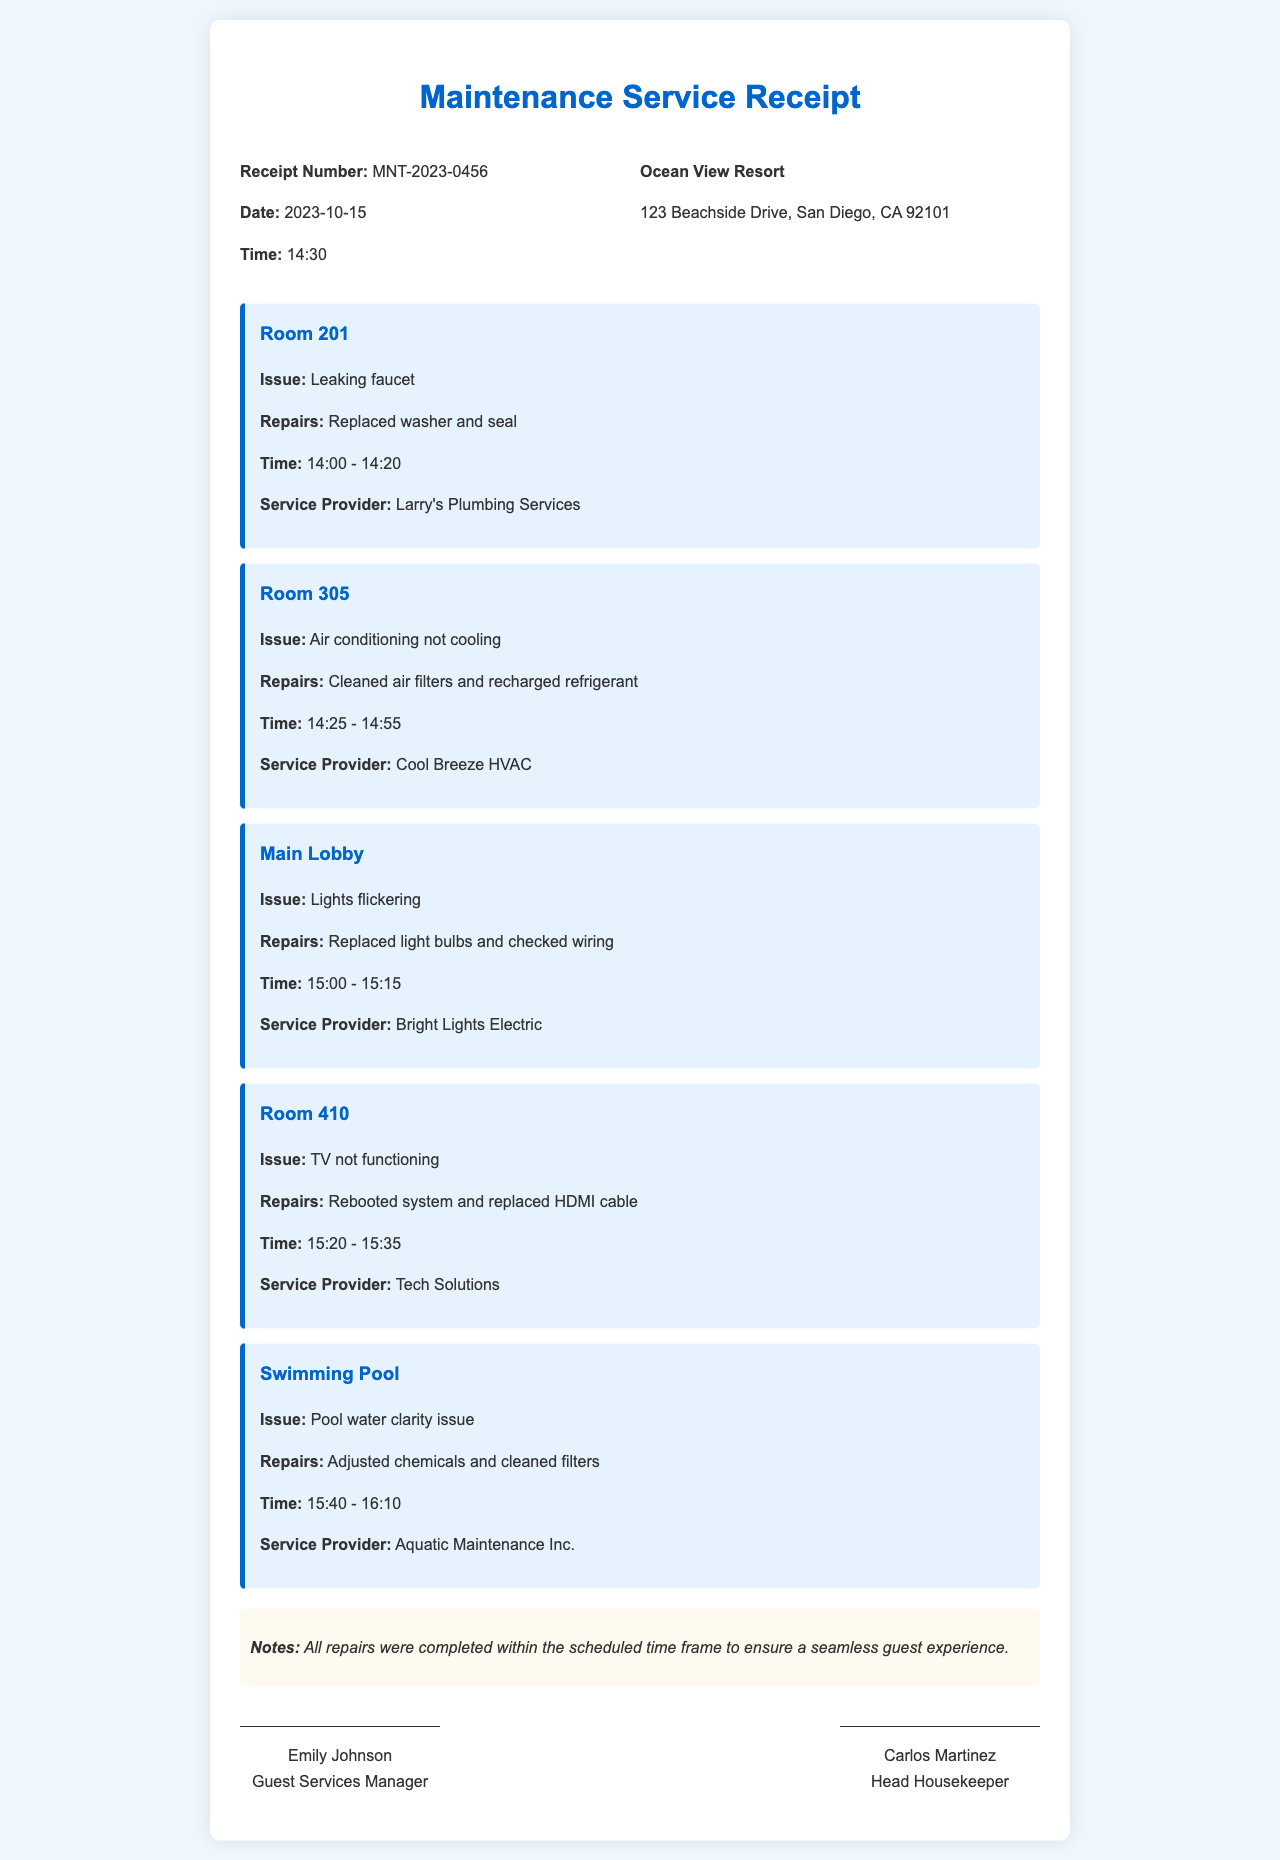What is the receipt number? The receipt number is a unique identifier for the maintenance service receipt, which is MNT-2023-0456.
Answer: MNT-2023-0456 What date was the maintenance service conducted? The date indicates when the maintenance service took place, which is 2023-10-15.
Answer: 2023-10-15 What issue was reported in Room 201? The issue in Room 201 is specified as a leaking faucet.
Answer: Leaking faucet What repairs were made in the swimming pool area? The repairs listed for the swimming pool include the adjustments made to its chemicals and cleaning of the filters.
Answer: Adjusted chemicals and cleaned filters How long did the air conditioning repair take? The duration of the air conditioning repair was noted, spanning from 14:25 to 14:55, which is a total of 30 minutes.
Answer: 30 minutes Which service provider handled the TV repair in Room 410? The document specifies that Tech Solutions was the provider for the repairs in Room 410.
Answer: Tech Solutions What was the note regarding the repairs? The note provides insight into the completion of repairs and emphasizes that they were performed to ensure guest satisfaction.
Answer: All repairs were completed within the scheduled time frame to ensure a seamless guest experience What time did the repair on the air conditioning in Room 305 start? The start time for the air conditioning repair is explicitly mentioned as 14:25.
Answer: 14:25 Who signed the receipt as Guest Services Manager? The signature section names Emily Johnson as the Guest Services Manager.
Answer: Emily Johnson 